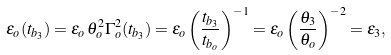<formula> <loc_0><loc_0><loc_500><loc_500>\epsilon _ { o } ( t _ { b _ { 3 } } ) = \epsilon _ { o } \, \theta _ { o } ^ { 2 } \Gamma _ { o } ^ { 2 } ( t _ { b _ { 3 } } ) = \epsilon _ { o } \left ( \frac { t _ { b _ { 3 } } } { t _ { b _ { o } } } \right ) ^ { - 1 } = \epsilon _ { o } \left ( \frac { \theta _ { 3 } } { \theta _ { o } } \right ) ^ { - 2 } = \epsilon _ { 3 } ,</formula> 